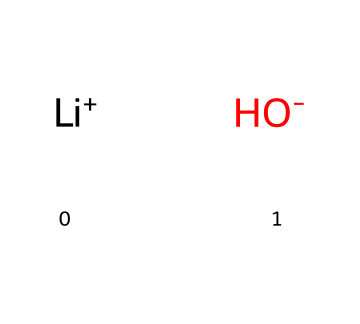What is the total number of atoms in lithium hydroxide? The chemical structure contains two different atoms: one lithium atom and one hydroxide ion, which itself consists of one oxygen atom and one hydrogen atom, totaling three atoms.
Answer: three What is the charge of lithium in this compound? In the SMILES representation, lithium is shown as [Li+], indicating that it has a positive charge.
Answer: positive How many hydroxide ions are present in lithium hydroxide? The representation includes one hydroxide ion indicated by [OH-], showing that there is one hydroxide ion per formula unit of lithium hydroxide.
Answer: one What type of compound is lithium hydroxide classified as? As it contains a metal cation (Li+) and a hydroxide anion (OH-), it is classified as a base.
Answer: base What role does lithium hydroxide play in spacecraft life support systems? Lithium hydroxide is utilized as a carbon dioxide scrubber, indicating that it helps to remove carbon dioxide from the air, which is essential for maintaining breathable conditions in spacecraft.
Answer: carbon dioxide scrubber Why is the hydroxide ion negatively charged? The hydroxide ion, represented as OH-, has an oxygen atom that bonds with a hydrogen atom and carries an extra electron, resulting in a negative charge on the ion.
Answer: negative charge 